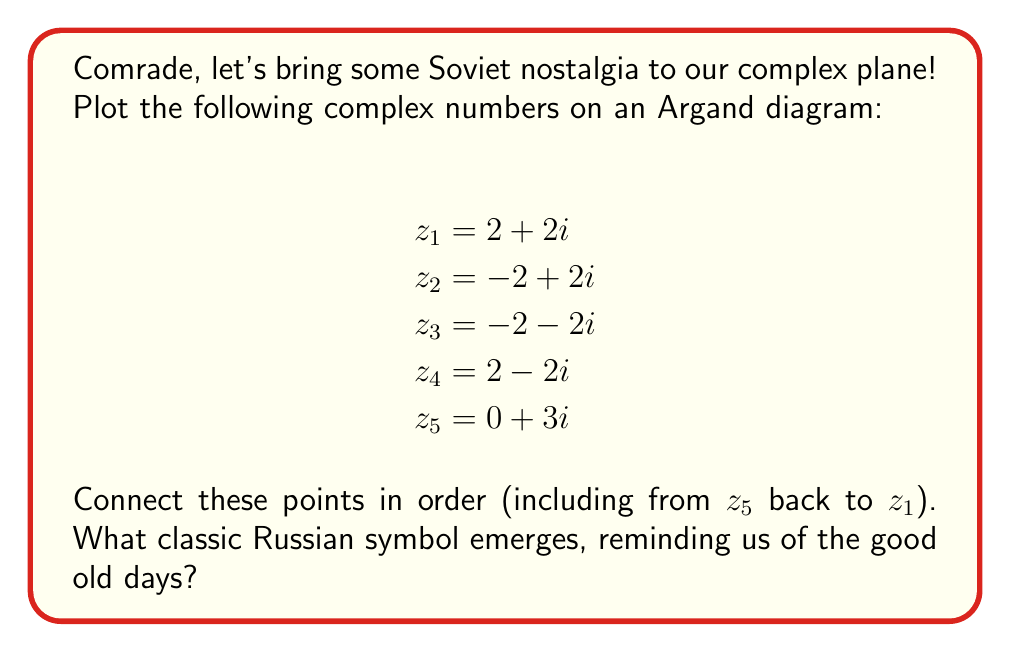Give your solution to this math problem. Let's plot these points step by step, comrade:

1) First, we'll plot each point on the complex plane:
   - $z_1 = 2 + 2i$ is 2 units right and 2 units up
   - $z_2 = -2 + 2i$ is 2 units left and 2 units up
   - $z_3 = -2 - 2i$ is 2 units left and 2 units down
   - $z_4 = 2 - 2i$ is 2 units right and 2 units down
   - $z_5 = 0 + 3i$ is 0 units right (on y-axis) and 3 units up

2) Now, let's connect these points in order:
   $z_1$ to $z_2$ to $z_3$ to $z_4$ to $z_5$ and back to $z_1$

3) The resulting shape forms a pentagon with a point at the top, resembling a star.

[asy]
import graph;
size(200);
real[] x = {2,-2,-2,2,0};
real[] y = {2,2,-2,-2,3};
for(int i=0; i<5; ++i) {
  dot((x[i],y[i]));
  label("$z_"+(string)(i+1)+"$", (x[i],y[i]), NE);
}
draw((2,2)--(-2,2)--(-2,-2)--(2,-2)--(0,3)--cycle);
xaxis("Re",arrow=Arrow);
yaxis("Im",arrow=Arrow);
[/asy]

This shape, my dear comrade, is none other than the glorious Red Star, a symbol that once adorned our great Soviet Union's flag and many other emblems. It represents the five fingers of the worker's hand or the five continents, depending on who you ask after a few shots of vodka.
Answer: The classic Russian symbol formed is the Red Star (Красная звезда). 